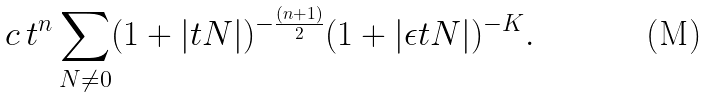<formula> <loc_0><loc_0><loc_500><loc_500>c \, t ^ { n } \sum _ { N \not = 0 } ( 1 + | t N | ) ^ { - \frac { ( n + 1 ) } { 2 } } ( 1 + | \epsilon t N | ) ^ { - K } .</formula> 